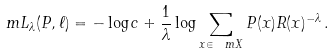Convert formula to latex. <formula><loc_0><loc_0><loc_500><loc_500>\ m { L } _ { \lambda } ( P , \ell ) = - \log { c } + \frac { 1 } { \lambda } \log \sum _ { x \in \ m { X } } P ( x ) R ( x ) ^ { - \lambda } \, .</formula> 